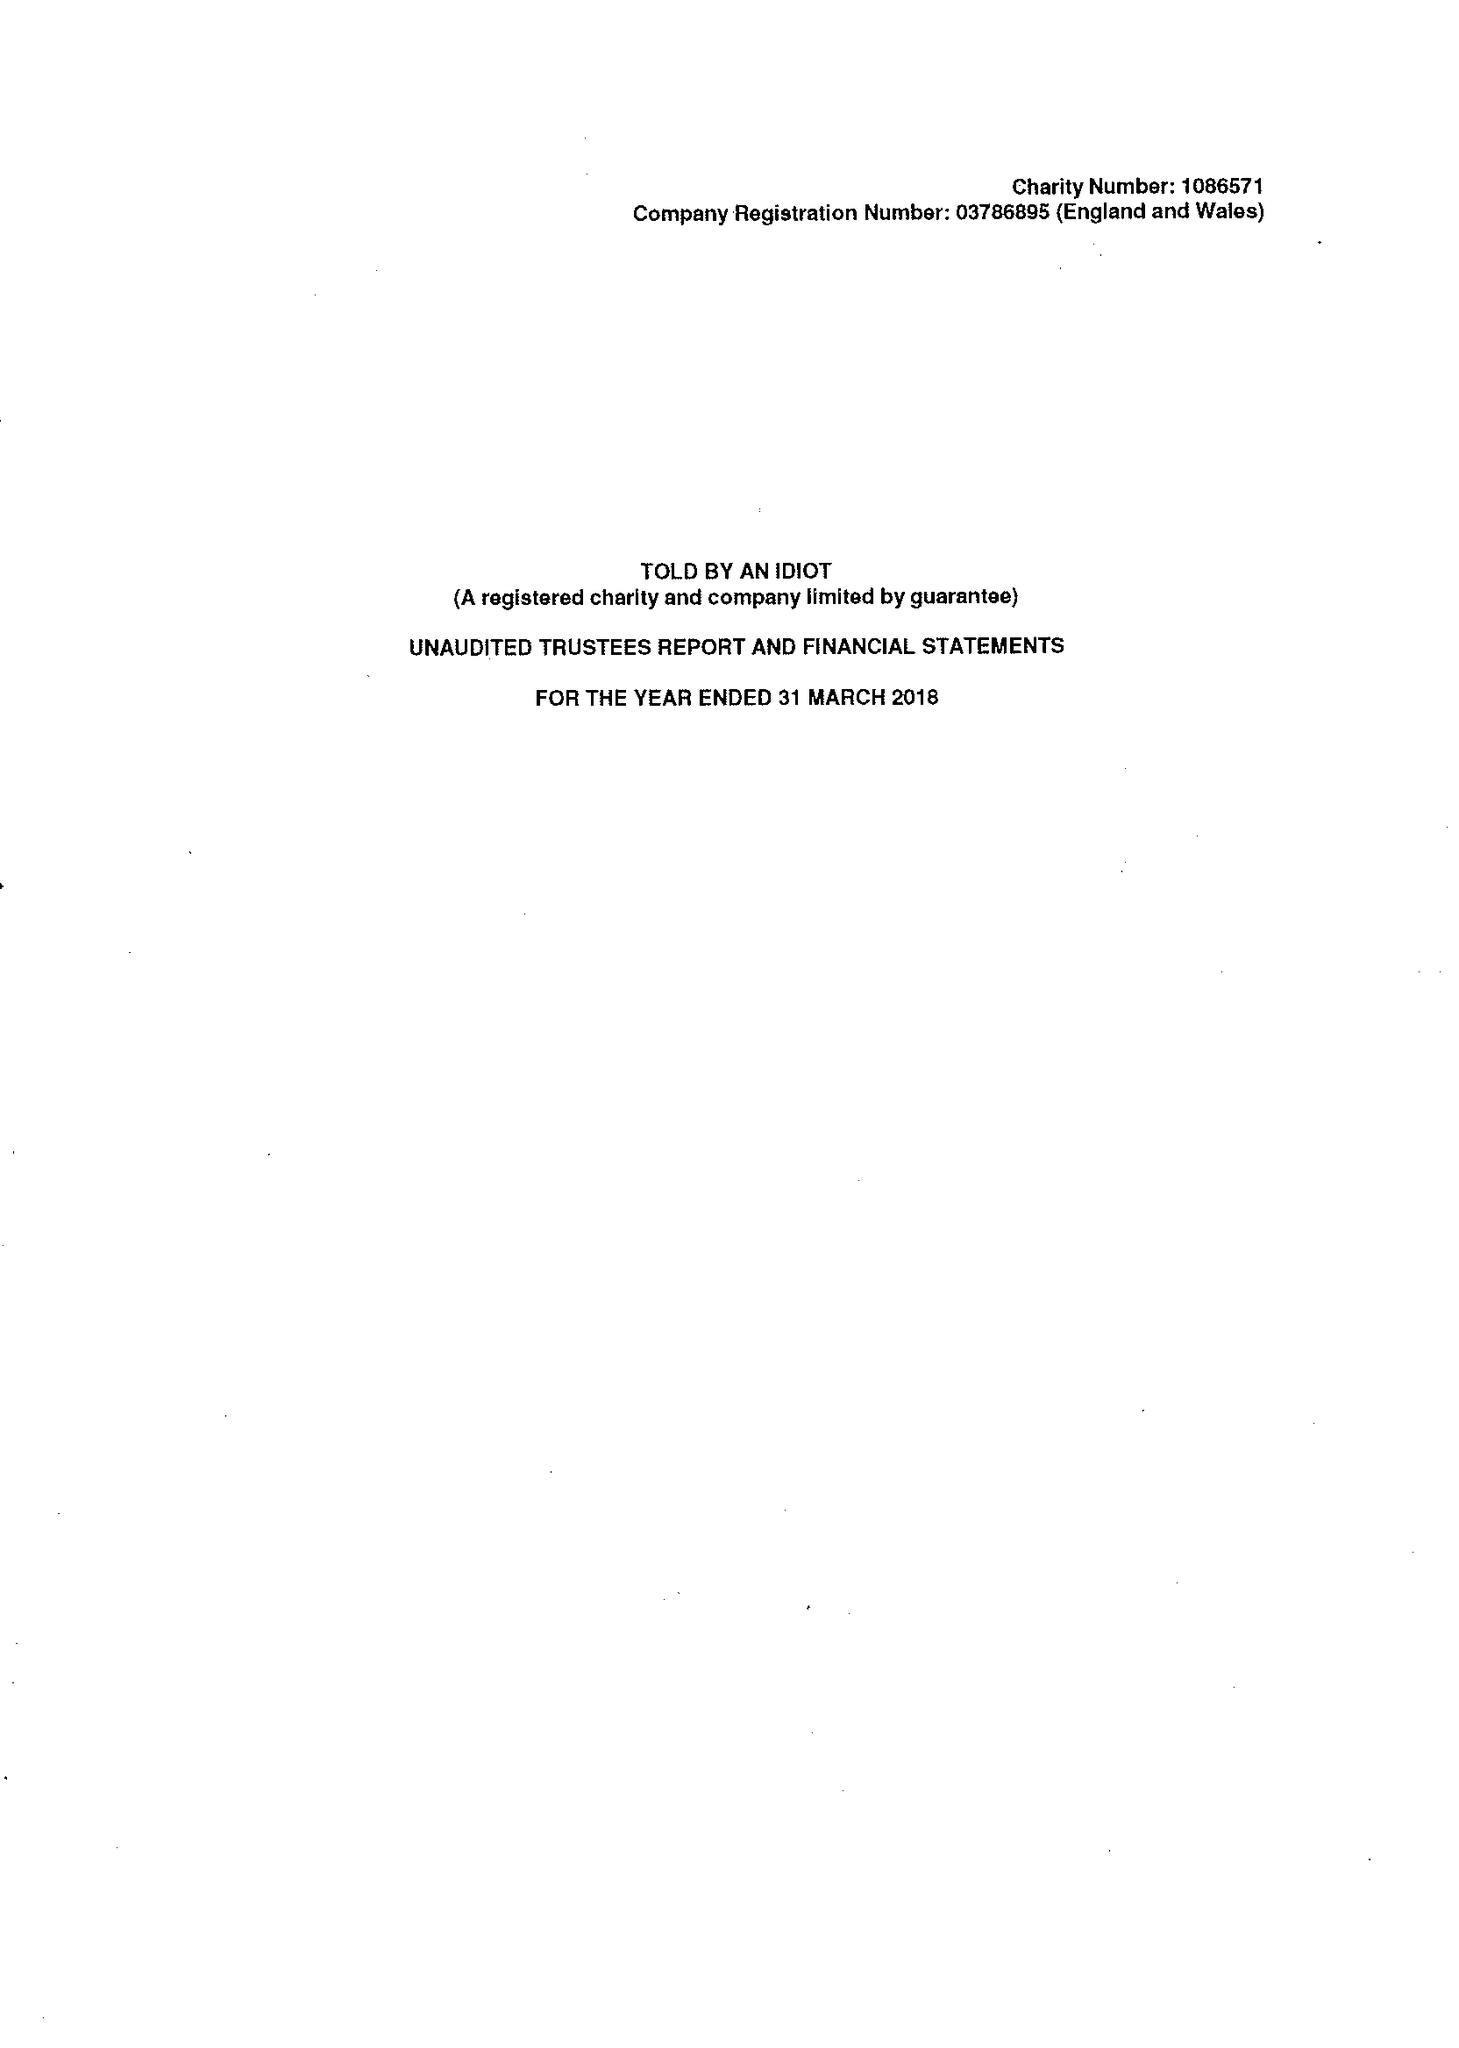What is the value for the address__postcode?
Answer the question using a single word or phrase. WC2N 4JS 